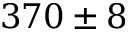<formula> <loc_0><loc_0><loc_500><loc_500>3 7 0 \pm 8</formula> 